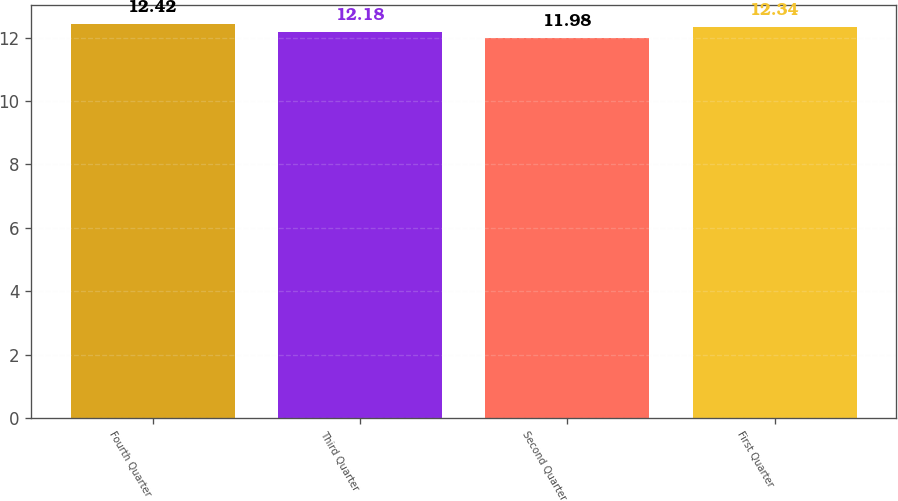<chart> <loc_0><loc_0><loc_500><loc_500><bar_chart><fcel>Fourth Quarter<fcel>Third Quarter<fcel>Second Quarter<fcel>First Quarter<nl><fcel>12.42<fcel>12.18<fcel>11.98<fcel>12.34<nl></chart> 